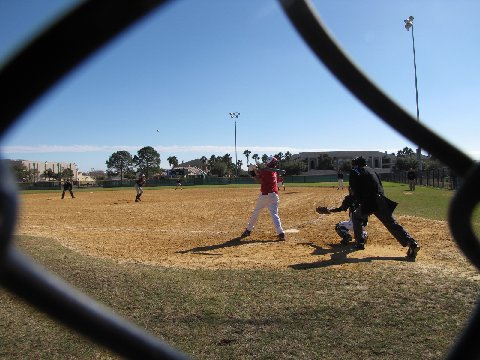What do the expressions and body language of the players tell us? The players exude an endearing blend of concentration and earnestness, with their postures emanating eagerness and alertness. The batter's focused gaze and tensed muscles mid-swing reveal a moment of high anticipation, while the poised stances of the surrounding players suggest readiness to react to the play's outcome. 